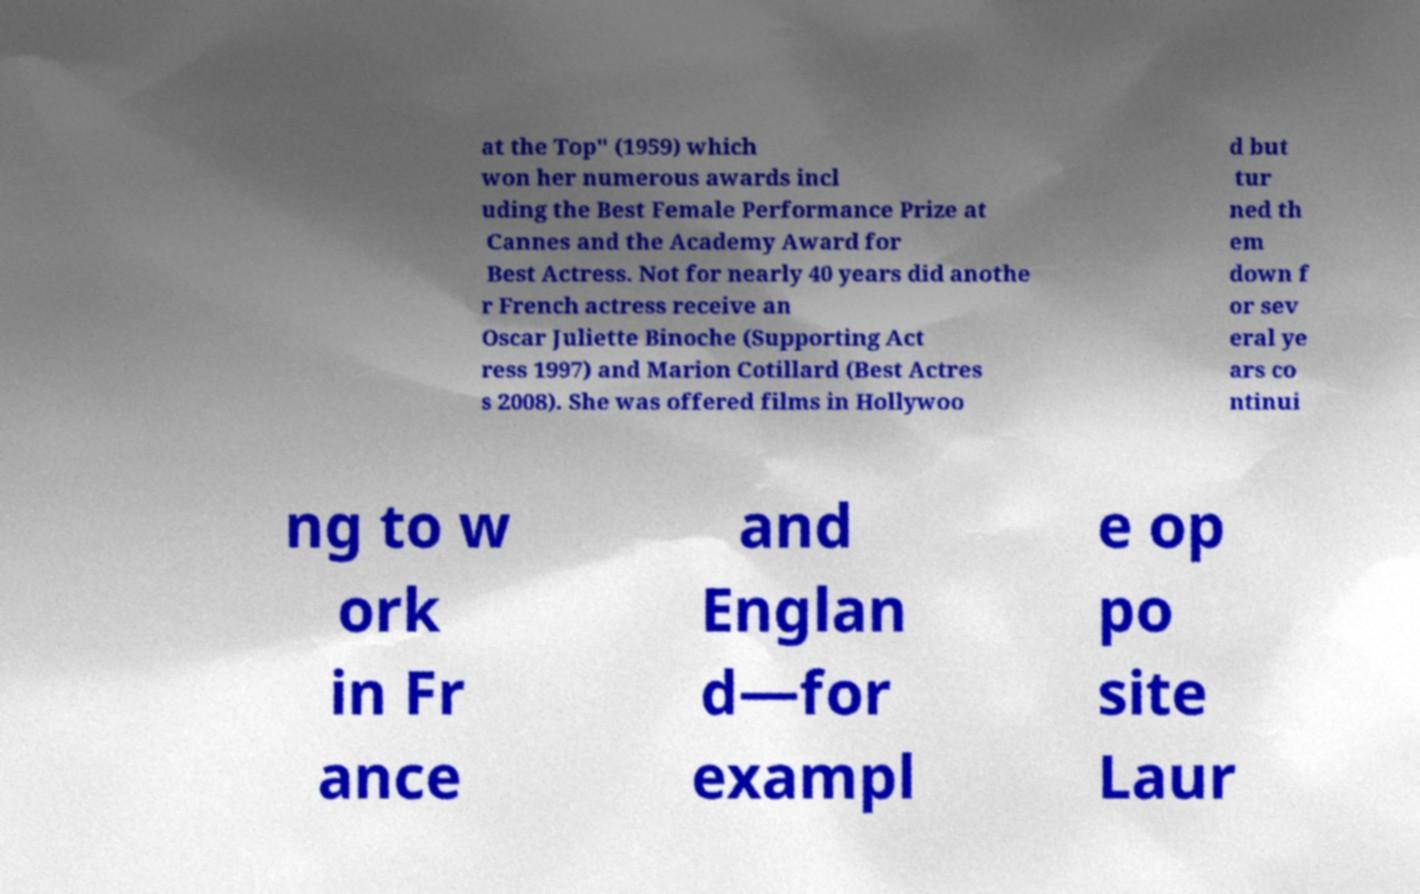Can you accurately transcribe the text from the provided image for me? at the Top" (1959) which won her numerous awards incl uding the Best Female Performance Prize at Cannes and the Academy Award for Best Actress. Not for nearly 40 years did anothe r French actress receive an Oscar Juliette Binoche (Supporting Act ress 1997) and Marion Cotillard (Best Actres s 2008). She was offered films in Hollywoo d but tur ned th em down f or sev eral ye ars co ntinui ng to w ork in Fr ance and Englan d—for exampl e op po site Laur 